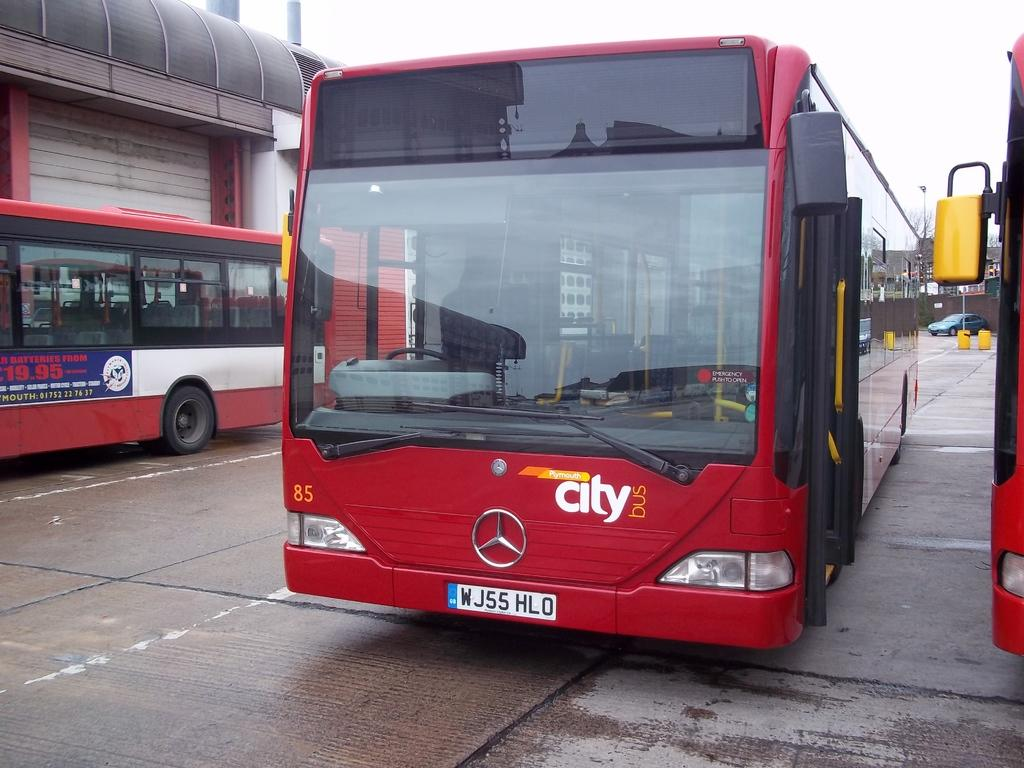Provide a one-sentence caption for the provided image. A city bus is parked without any indication of it's route showing. 